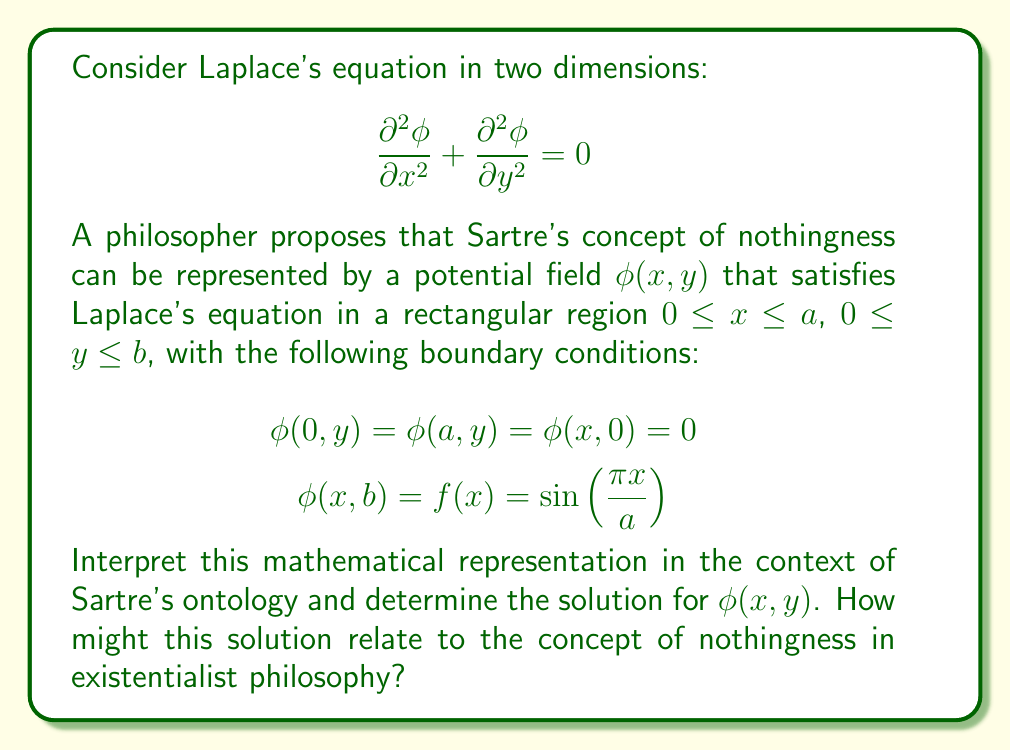Can you answer this question? To solve this problem, we need to approach it from both mathematical and philosophical perspectives:

1. Mathematical Solution:
We can solve Laplace's equation using separation of variables. Let $\phi(x,y) = X(x)Y(y)$.

Substituting into Laplace's equation:
$$X''Y + XY'' = 0$$
$$\frac{X''}{X} = -\frac{Y''}{Y} = -\lambda^2$$

This gives us two ordinary differential equations:
$$X'' + \lambda^2 X = 0$$
$$Y'' - \lambda^2 Y = 0$$

The general solutions are:
$$X(x) = A \sin(\lambda x) + B \cos(\lambda x)$$
$$Y(y) = C e^{\lambda y} + D e^{-\lambda y}$$

Applying the boundary conditions:

a) $\phi(0,y) = 0$ implies $B = 0$
b) $\phi(a,y) = 0$ implies $\lambda = \frac{n\pi}{a}$, where $n$ is a positive integer
c) $\phi(x,0) = 0$ implies $C = -D$

The solution that satisfies these conditions is:
$$\phi(x,y) = \sum_{n=1}^{\infty} A_n \sin(\frac{n\pi x}{a}) \sinh(\frac{n\pi y}{a})$$

To satisfy the final boundary condition $\phi(x,b) = \sin(\frac{\pi x}{a})$, we need only the $n=1$ term, giving:

$$\phi(x,y) = \frac{\sin(\frac{\pi x}{a}) \sinh(\frac{\pi y}{a})}{\sinh(\frac{\pi b}{a})}$$

2. Philosophical Interpretation:

In Sartre's ontology, nothingness is not merely the absence of being but an active force that negates and separates beings. The solution $\phi(x,y)$ can be interpreted as follows:

a) The zero boundary conditions on three sides represent the void or nothingness that surrounds being.

b) The non-zero boundary condition $f(x) = \sin(\frac{\pi x}{a})$ at $y=b$ represents the emergence of being or consciousness from nothingness.

c) The solution $\phi(x,y)$ shows how being (represented by non-zero values) emerges gradually from nothingness (zero values) as we move from the zero boundaries towards the center and upper part of the region.

d) The sinusoidal nature of the solution reflects the oscillation between being and nothingness that Sartre describes in his philosophy.

e) The decay of the solution as we move away from the non-zero boundary (y decreases) could represent the constant threat of nothingness to being, a key concept in Sartre's existentialism.

This mathematical representation provides a visual and quantitative way to explore Sartre's abstract concepts, potentially offering new insights into the relationship between being and nothingness in existentialist philosophy.
Answer: The solution to the given Laplace equation with the specified boundary conditions is:

$$\phi(x,y) = \frac{\sin(\frac{\pi x}{a}) \sinh(\frac{\pi y}{a})}{\sinh(\frac{\pi b}{a})}$$

This solution represents a potential field that can be interpreted as a mathematical model for Sartre's concept of nothingness, illustrating the emergence of being from nothingness and the constant interplay between the two in existentialist philosophy. 